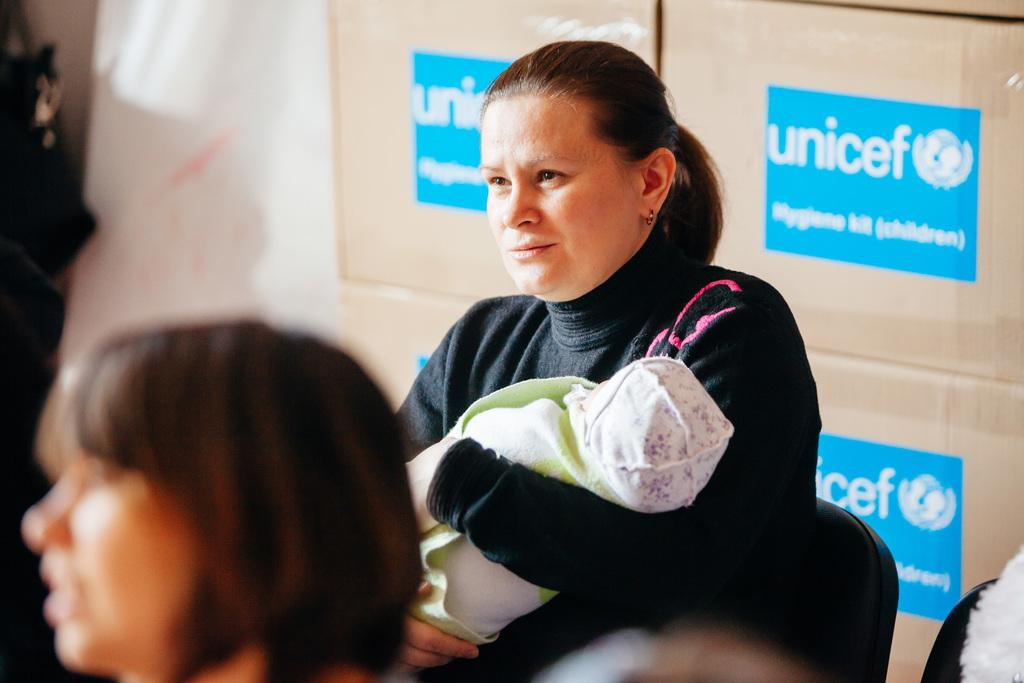What is the woman in the image doing? There is a woman holding a baby in the image. How many women are present in the image? There are two women in the image. What can be seen in the background of the image? There is text visible in the background of the image. What type of drink is the baby holding in the image? There is no drink present in the image, as the baby is being held by the woman. 